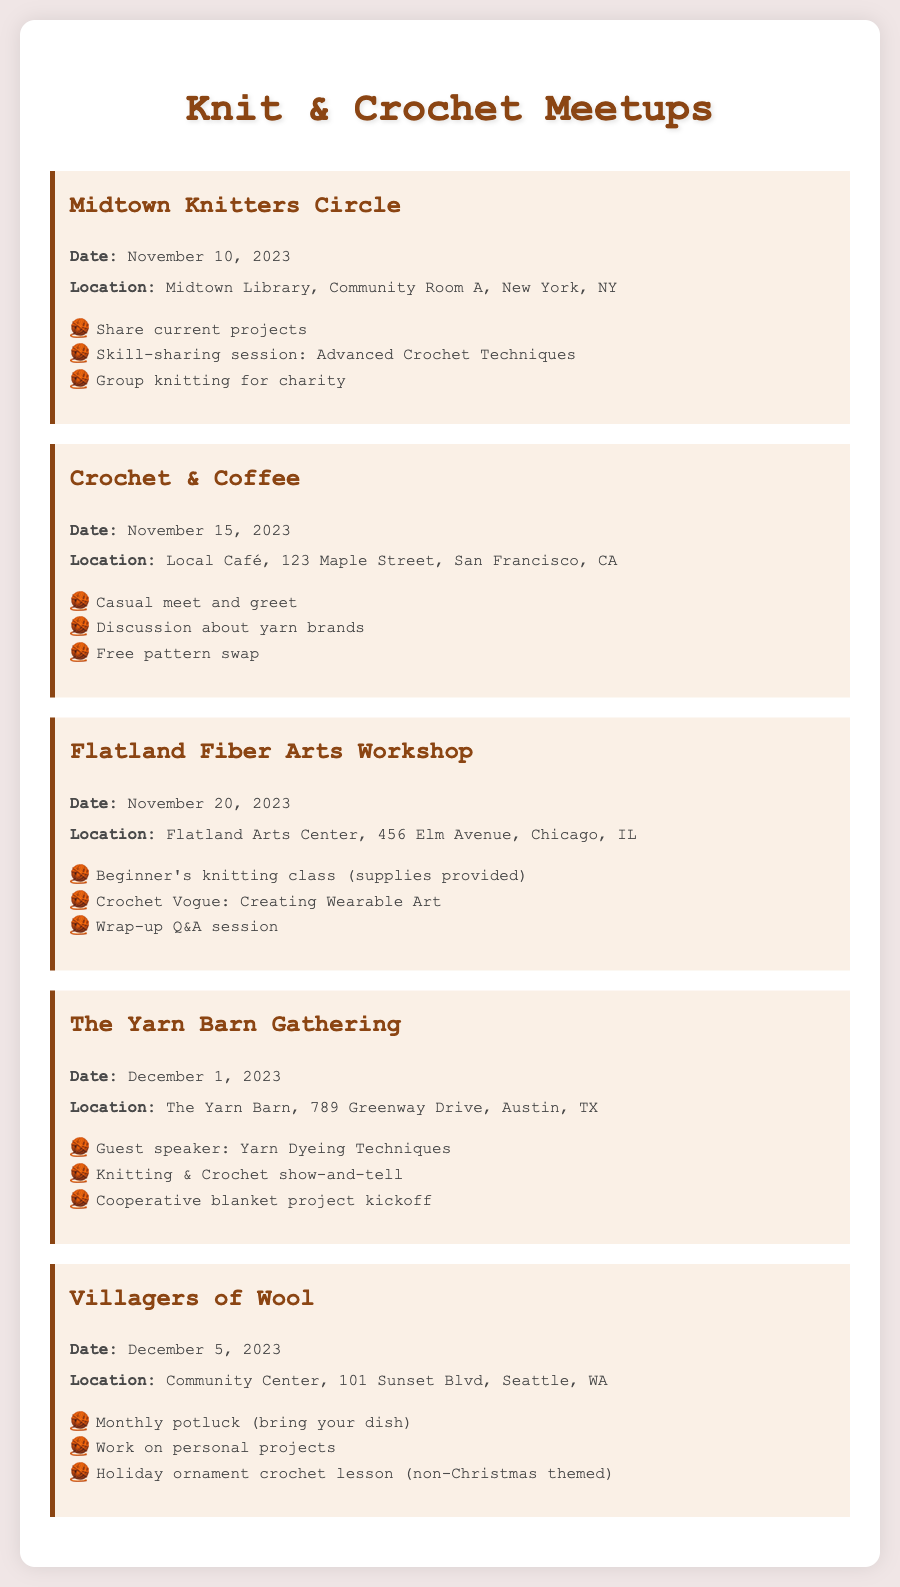what is the date of the Midtown Knitters Circle? The date is explicitly provided in the document for this meetup as November 10, 2023.
Answer: November 10, 2023 where is the Crochet & Coffee meetup held? The location is specified in the document as Local Café, 123 Maple Street, San Francisco, CA.
Answer: Local Café, 123 Maple Street, San Francisco, CA how many activities are planned for the Flatland Fiber Arts Workshop? The document lists three activities under this workshop, making it a count of three.
Answer: 3 which meetup features a guest speaker? The Yarn Barn Gathering is mentioned in the document as having a guest speaker about Yarn Dyeing Techniques.
Answer: The Yarn Barn Gathering what type of lesson is included in the Villagers of Wool meetup? The document indicates that the lesson is a Holiday ornament crochet lesson, specifically noted as non-Christmas themed.
Answer: Holiday ornament crochet lesson (non-Christmas themed) when does the Crochet & Coffee meetup take place? The document provides the date as November 15, 2023, for this specific meetup.
Answer: November 15, 2023 which location hosts the beginner's knitting class? The Flatland Arts Center is identified in the document as the location for the beginner's knitting class.
Answer: Flatland Arts Center what activity involves working on personal projects? The Villagers of Wool meetup includes the activity of working on personal projects as stated in the document.
Answer: Work on personal projects 